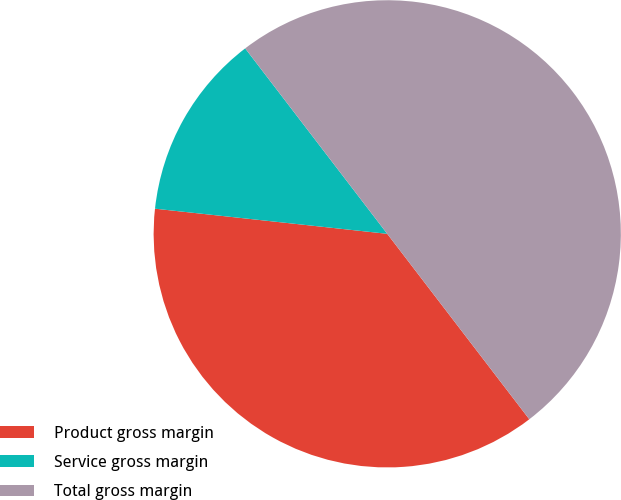<chart> <loc_0><loc_0><loc_500><loc_500><pie_chart><fcel>Product gross margin<fcel>Service gross margin<fcel>Total gross margin<nl><fcel>37.12%<fcel>12.88%<fcel>50.0%<nl></chart> 